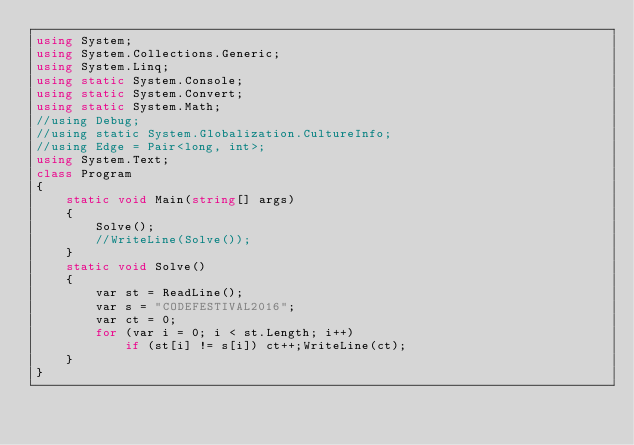Convert code to text. <code><loc_0><loc_0><loc_500><loc_500><_C#_>using System;
using System.Collections.Generic;
using System.Linq;
using static System.Console;
using static System.Convert;
using static System.Math;
//using Debug;
//using static System.Globalization.CultureInfo;
//using Edge = Pair<long, int>;
using System.Text;
class Program
{ 
    static void Main(string[] args)
    {
        Solve();
        //WriteLine(Solve());
    }
    static void Solve()
    {
        var st = ReadLine();
        var s = "CODEFESTIVAL2016";
        var ct = 0;
        for (var i = 0; i < st.Length; i++)
            if (st[i] != s[i]) ct++;WriteLine(ct);
    }
}
</code> 